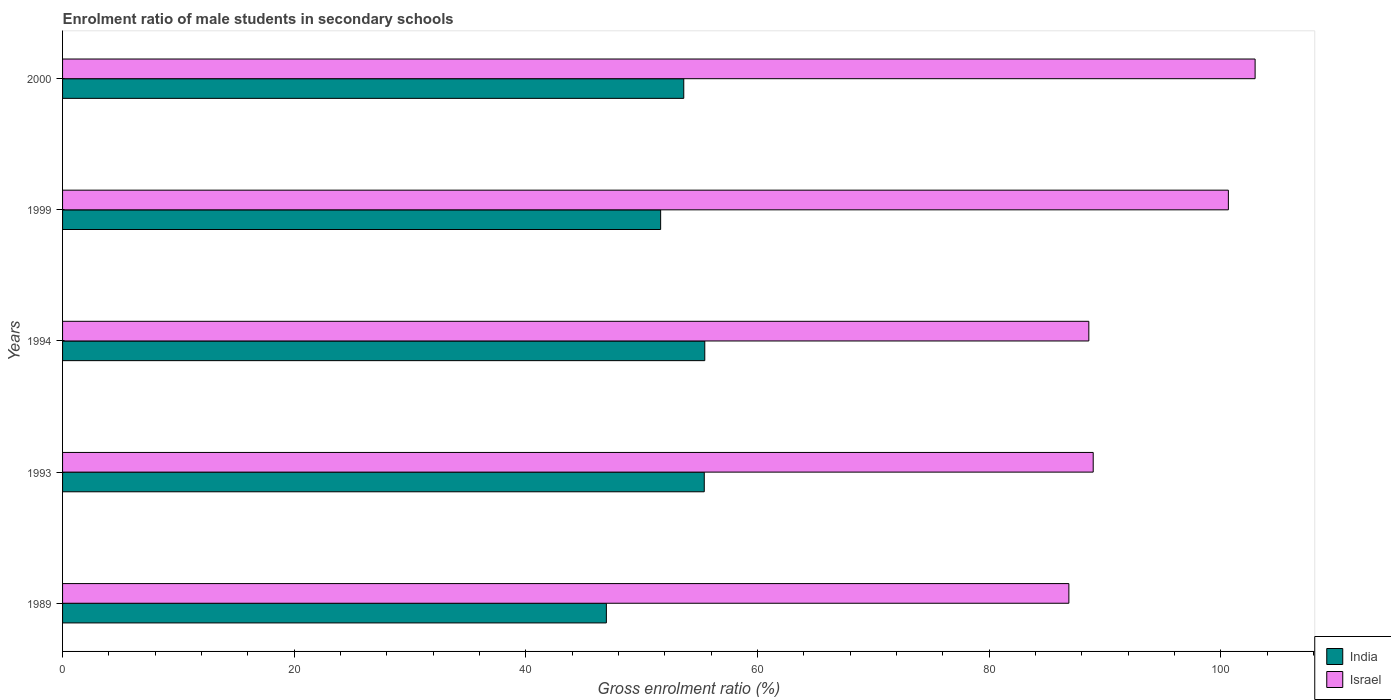How many bars are there on the 3rd tick from the top?
Offer a terse response. 2. How many bars are there on the 1st tick from the bottom?
Offer a very short reply. 2. In how many cases, is the number of bars for a given year not equal to the number of legend labels?
Give a very brief answer. 0. What is the enrolment ratio of male students in secondary schools in Israel in 2000?
Provide a short and direct response. 102.97. Across all years, what is the maximum enrolment ratio of male students in secondary schools in India?
Offer a terse response. 55.45. Across all years, what is the minimum enrolment ratio of male students in secondary schools in Israel?
Ensure brevity in your answer.  86.89. In which year was the enrolment ratio of male students in secondary schools in India maximum?
Your answer should be very brief. 1994. In which year was the enrolment ratio of male students in secondary schools in India minimum?
Your answer should be very brief. 1989. What is the total enrolment ratio of male students in secondary schools in Israel in the graph?
Offer a very short reply. 468.12. What is the difference between the enrolment ratio of male students in secondary schools in India in 1993 and that in 2000?
Give a very brief answer. 1.77. What is the difference between the enrolment ratio of male students in secondary schools in Israel in 2000 and the enrolment ratio of male students in secondary schools in India in 1989?
Offer a very short reply. 56.01. What is the average enrolment ratio of male students in secondary schools in Israel per year?
Give a very brief answer. 93.62. In the year 1994, what is the difference between the enrolment ratio of male students in secondary schools in India and enrolment ratio of male students in secondary schools in Israel?
Your answer should be compact. -33.16. In how many years, is the enrolment ratio of male students in secondary schools in Israel greater than 12 %?
Offer a terse response. 5. What is the ratio of the enrolment ratio of male students in secondary schools in India in 1989 to that in 1999?
Keep it short and to the point. 0.91. Is the difference between the enrolment ratio of male students in secondary schools in India in 1989 and 1994 greater than the difference between the enrolment ratio of male students in secondary schools in Israel in 1989 and 1994?
Give a very brief answer. No. What is the difference between the highest and the second highest enrolment ratio of male students in secondary schools in India?
Offer a terse response. 0.04. What is the difference between the highest and the lowest enrolment ratio of male students in secondary schools in India?
Your response must be concise. 8.5. How many bars are there?
Offer a very short reply. 10. Are all the bars in the graph horizontal?
Your answer should be very brief. Yes. How many years are there in the graph?
Ensure brevity in your answer.  5. Does the graph contain any zero values?
Offer a terse response. No. Does the graph contain grids?
Your answer should be compact. No. Where does the legend appear in the graph?
Provide a succinct answer. Bottom right. How many legend labels are there?
Offer a very short reply. 2. What is the title of the graph?
Give a very brief answer. Enrolment ratio of male students in secondary schools. Does "East Asia (developing only)" appear as one of the legend labels in the graph?
Provide a succinct answer. No. What is the label or title of the X-axis?
Provide a short and direct response. Gross enrolment ratio (%). What is the Gross enrolment ratio (%) in India in 1989?
Provide a short and direct response. 46.95. What is the Gross enrolment ratio (%) of Israel in 1989?
Your response must be concise. 86.89. What is the Gross enrolment ratio (%) in India in 1993?
Offer a terse response. 55.41. What is the Gross enrolment ratio (%) in Israel in 1993?
Offer a terse response. 88.99. What is the Gross enrolment ratio (%) of India in 1994?
Provide a succinct answer. 55.45. What is the Gross enrolment ratio (%) in Israel in 1994?
Provide a short and direct response. 88.61. What is the Gross enrolment ratio (%) of India in 1999?
Offer a very short reply. 51.64. What is the Gross enrolment ratio (%) of Israel in 1999?
Your response must be concise. 100.66. What is the Gross enrolment ratio (%) of India in 2000?
Your answer should be compact. 53.64. What is the Gross enrolment ratio (%) of Israel in 2000?
Offer a terse response. 102.97. Across all years, what is the maximum Gross enrolment ratio (%) of India?
Your response must be concise. 55.45. Across all years, what is the maximum Gross enrolment ratio (%) in Israel?
Your response must be concise. 102.97. Across all years, what is the minimum Gross enrolment ratio (%) in India?
Ensure brevity in your answer.  46.95. Across all years, what is the minimum Gross enrolment ratio (%) in Israel?
Give a very brief answer. 86.89. What is the total Gross enrolment ratio (%) of India in the graph?
Provide a succinct answer. 263.09. What is the total Gross enrolment ratio (%) of Israel in the graph?
Provide a succinct answer. 468.12. What is the difference between the Gross enrolment ratio (%) in India in 1989 and that in 1993?
Give a very brief answer. -8.45. What is the difference between the Gross enrolment ratio (%) in Israel in 1989 and that in 1993?
Ensure brevity in your answer.  -2.1. What is the difference between the Gross enrolment ratio (%) in India in 1989 and that in 1994?
Offer a terse response. -8.5. What is the difference between the Gross enrolment ratio (%) in Israel in 1989 and that in 1994?
Your response must be concise. -1.72. What is the difference between the Gross enrolment ratio (%) of India in 1989 and that in 1999?
Your answer should be very brief. -4.68. What is the difference between the Gross enrolment ratio (%) in Israel in 1989 and that in 1999?
Your response must be concise. -13.77. What is the difference between the Gross enrolment ratio (%) of India in 1989 and that in 2000?
Keep it short and to the point. -6.68. What is the difference between the Gross enrolment ratio (%) in Israel in 1989 and that in 2000?
Offer a terse response. -16.08. What is the difference between the Gross enrolment ratio (%) of India in 1993 and that in 1994?
Provide a short and direct response. -0.04. What is the difference between the Gross enrolment ratio (%) in Israel in 1993 and that in 1994?
Ensure brevity in your answer.  0.38. What is the difference between the Gross enrolment ratio (%) in India in 1993 and that in 1999?
Your answer should be very brief. 3.77. What is the difference between the Gross enrolment ratio (%) in Israel in 1993 and that in 1999?
Keep it short and to the point. -11.67. What is the difference between the Gross enrolment ratio (%) of India in 1993 and that in 2000?
Your response must be concise. 1.77. What is the difference between the Gross enrolment ratio (%) of Israel in 1993 and that in 2000?
Keep it short and to the point. -13.98. What is the difference between the Gross enrolment ratio (%) in India in 1994 and that in 1999?
Your answer should be very brief. 3.81. What is the difference between the Gross enrolment ratio (%) in Israel in 1994 and that in 1999?
Provide a short and direct response. -12.05. What is the difference between the Gross enrolment ratio (%) of India in 1994 and that in 2000?
Your response must be concise. 1.81. What is the difference between the Gross enrolment ratio (%) in Israel in 1994 and that in 2000?
Your response must be concise. -14.36. What is the difference between the Gross enrolment ratio (%) of India in 1999 and that in 2000?
Your answer should be compact. -2. What is the difference between the Gross enrolment ratio (%) of Israel in 1999 and that in 2000?
Your response must be concise. -2.31. What is the difference between the Gross enrolment ratio (%) in India in 1989 and the Gross enrolment ratio (%) in Israel in 1993?
Offer a very short reply. -42.03. What is the difference between the Gross enrolment ratio (%) in India in 1989 and the Gross enrolment ratio (%) in Israel in 1994?
Ensure brevity in your answer.  -41.66. What is the difference between the Gross enrolment ratio (%) in India in 1989 and the Gross enrolment ratio (%) in Israel in 1999?
Give a very brief answer. -53.71. What is the difference between the Gross enrolment ratio (%) in India in 1989 and the Gross enrolment ratio (%) in Israel in 2000?
Make the answer very short. -56.01. What is the difference between the Gross enrolment ratio (%) in India in 1993 and the Gross enrolment ratio (%) in Israel in 1994?
Ensure brevity in your answer.  -33.2. What is the difference between the Gross enrolment ratio (%) in India in 1993 and the Gross enrolment ratio (%) in Israel in 1999?
Make the answer very short. -45.25. What is the difference between the Gross enrolment ratio (%) in India in 1993 and the Gross enrolment ratio (%) in Israel in 2000?
Provide a short and direct response. -47.56. What is the difference between the Gross enrolment ratio (%) in India in 1994 and the Gross enrolment ratio (%) in Israel in 1999?
Your answer should be very brief. -45.21. What is the difference between the Gross enrolment ratio (%) in India in 1994 and the Gross enrolment ratio (%) in Israel in 2000?
Give a very brief answer. -47.52. What is the difference between the Gross enrolment ratio (%) in India in 1999 and the Gross enrolment ratio (%) in Israel in 2000?
Your answer should be compact. -51.33. What is the average Gross enrolment ratio (%) in India per year?
Your response must be concise. 52.62. What is the average Gross enrolment ratio (%) of Israel per year?
Your answer should be very brief. 93.62. In the year 1989, what is the difference between the Gross enrolment ratio (%) in India and Gross enrolment ratio (%) in Israel?
Your answer should be very brief. -39.93. In the year 1993, what is the difference between the Gross enrolment ratio (%) of India and Gross enrolment ratio (%) of Israel?
Provide a succinct answer. -33.58. In the year 1994, what is the difference between the Gross enrolment ratio (%) of India and Gross enrolment ratio (%) of Israel?
Your response must be concise. -33.16. In the year 1999, what is the difference between the Gross enrolment ratio (%) in India and Gross enrolment ratio (%) in Israel?
Offer a terse response. -49.02. In the year 2000, what is the difference between the Gross enrolment ratio (%) in India and Gross enrolment ratio (%) in Israel?
Your answer should be compact. -49.33. What is the ratio of the Gross enrolment ratio (%) in India in 1989 to that in 1993?
Your response must be concise. 0.85. What is the ratio of the Gross enrolment ratio (%) in Israel in 1989 to that in 1993?
Your response must be concise. 0.98. What is the ratio of the Gross enrolment ratio (%) in India in 1989 to that in 1994?
Offer a terse response. 0.85. What is the ratio of the Gross enrolment ratio (%) in Israel in 1989 to that in 1994?
Provide a short and direct response. 0.98. What is the ratio of the Gross enrolment ratio (%) of India in 1989 to that in 1999?
Offer a terse response. 0.91. What is the ratio of the Gross enrolment ratio (%) in Israel in 1989 to that in 1999?
Offer a very short reply. 0.86. What is the ratio of the Gross enrolment ratio (%) of India in 1989 to that in 2000?
Ensure brevity in your answer.  0.88. What is the ratio of the Gross enrolment ratio (%) in Israel in 1989 to that in 2000?
Your answer should be very brief. 0.84. What is the ratio of the Gross enrolment ratio (%) in India in 1993 to that in 1999?
Your answer should be compact. 1.07. What is the ratio of the Gross enrolment ratio (%) in Israel in 1993 to that in 1999?
Give a very brief answer. 0.88. What is the ratio of the Gross enrolment ratio (%) in India in 1993 to that in 2000?
Your answer should be compact. 1.03. What is the ratio of the Gross enrolment ratio (%) of Israel in 1993 to that in 2000?
Provide a short and direct response. 0.86. What is the ratio of the Gross enrolment ratio (%) of India in 1994 to that in 1999?
Keep it short and to the point. 1.07. What is the ratio of the Gross enrolment ratio (%) in Israel in 1994 to that in 1999?
Offer a terse response. 0.88. What is the ratio of the Gross enrolment ratio (%) in India in 1994 to that in 2000?
Keep it short and to the point. 1.03. What is the ratio of the Gross enrolment ratio (%) of Israel in 1994 to that in 2000?
Your answer should be very brief. 0.86. What is the ratio of the Gross enrolment ratio (%) of India in 1999 to that in 2000?
Offer a very short reply. 0.96. What is the ratio of the Gross enrolment ratio (%) of Israel in 1999 to that in 2000?
Your answer should be very brief. 0.98. What is the difference between the highest and the second highest Gross enrolment ratio (%) in India?
Make the answer very short. 0.04. What is the difference between the highest and the second highest Gross enrolment ratio (%) of Israel?
Your response must be concise. 2.31. What is the difference between the highest and the lowest Gross enrolment ratio (%) in India?
Offer a terse response. 8.5. What is the difference between the highest and the lowest Gross enrolment ratio (%) in Israel?
Your answer should be very brief. 16.08. 